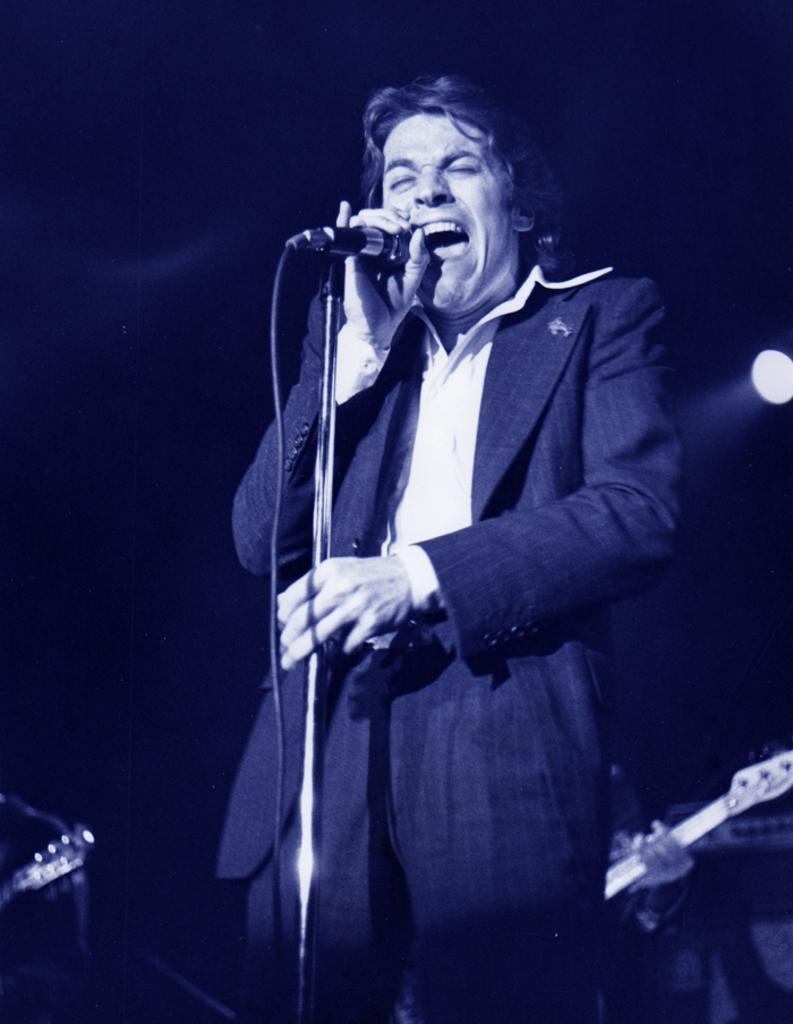Describe this image in one or two sentences. In this picture we can see a man standing in front of a microphone and holding a microphone, he is speaking something as we can see his mouth, in the background a person is holding a guitar and also we can see a light in the background. 